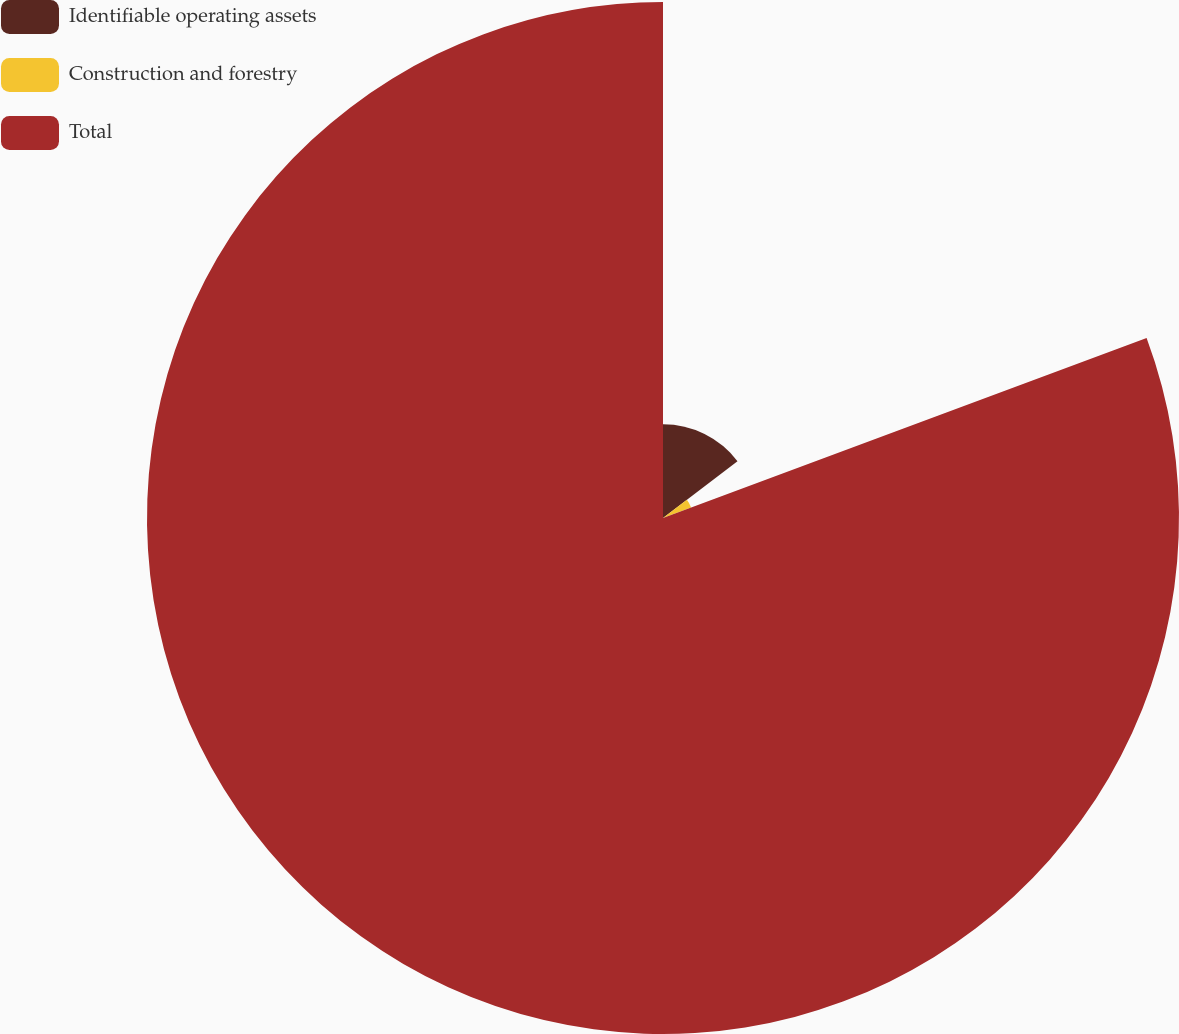<chart> <loc_0><loc_0><loc_500><loc_500><pie_chart><fcel>Identifiable operating assets<fcel>Construction and forestry<fcel>Total<nl><fcel>14.64%<fcel>4.69%<fcel>80.67%<nl></chart> 